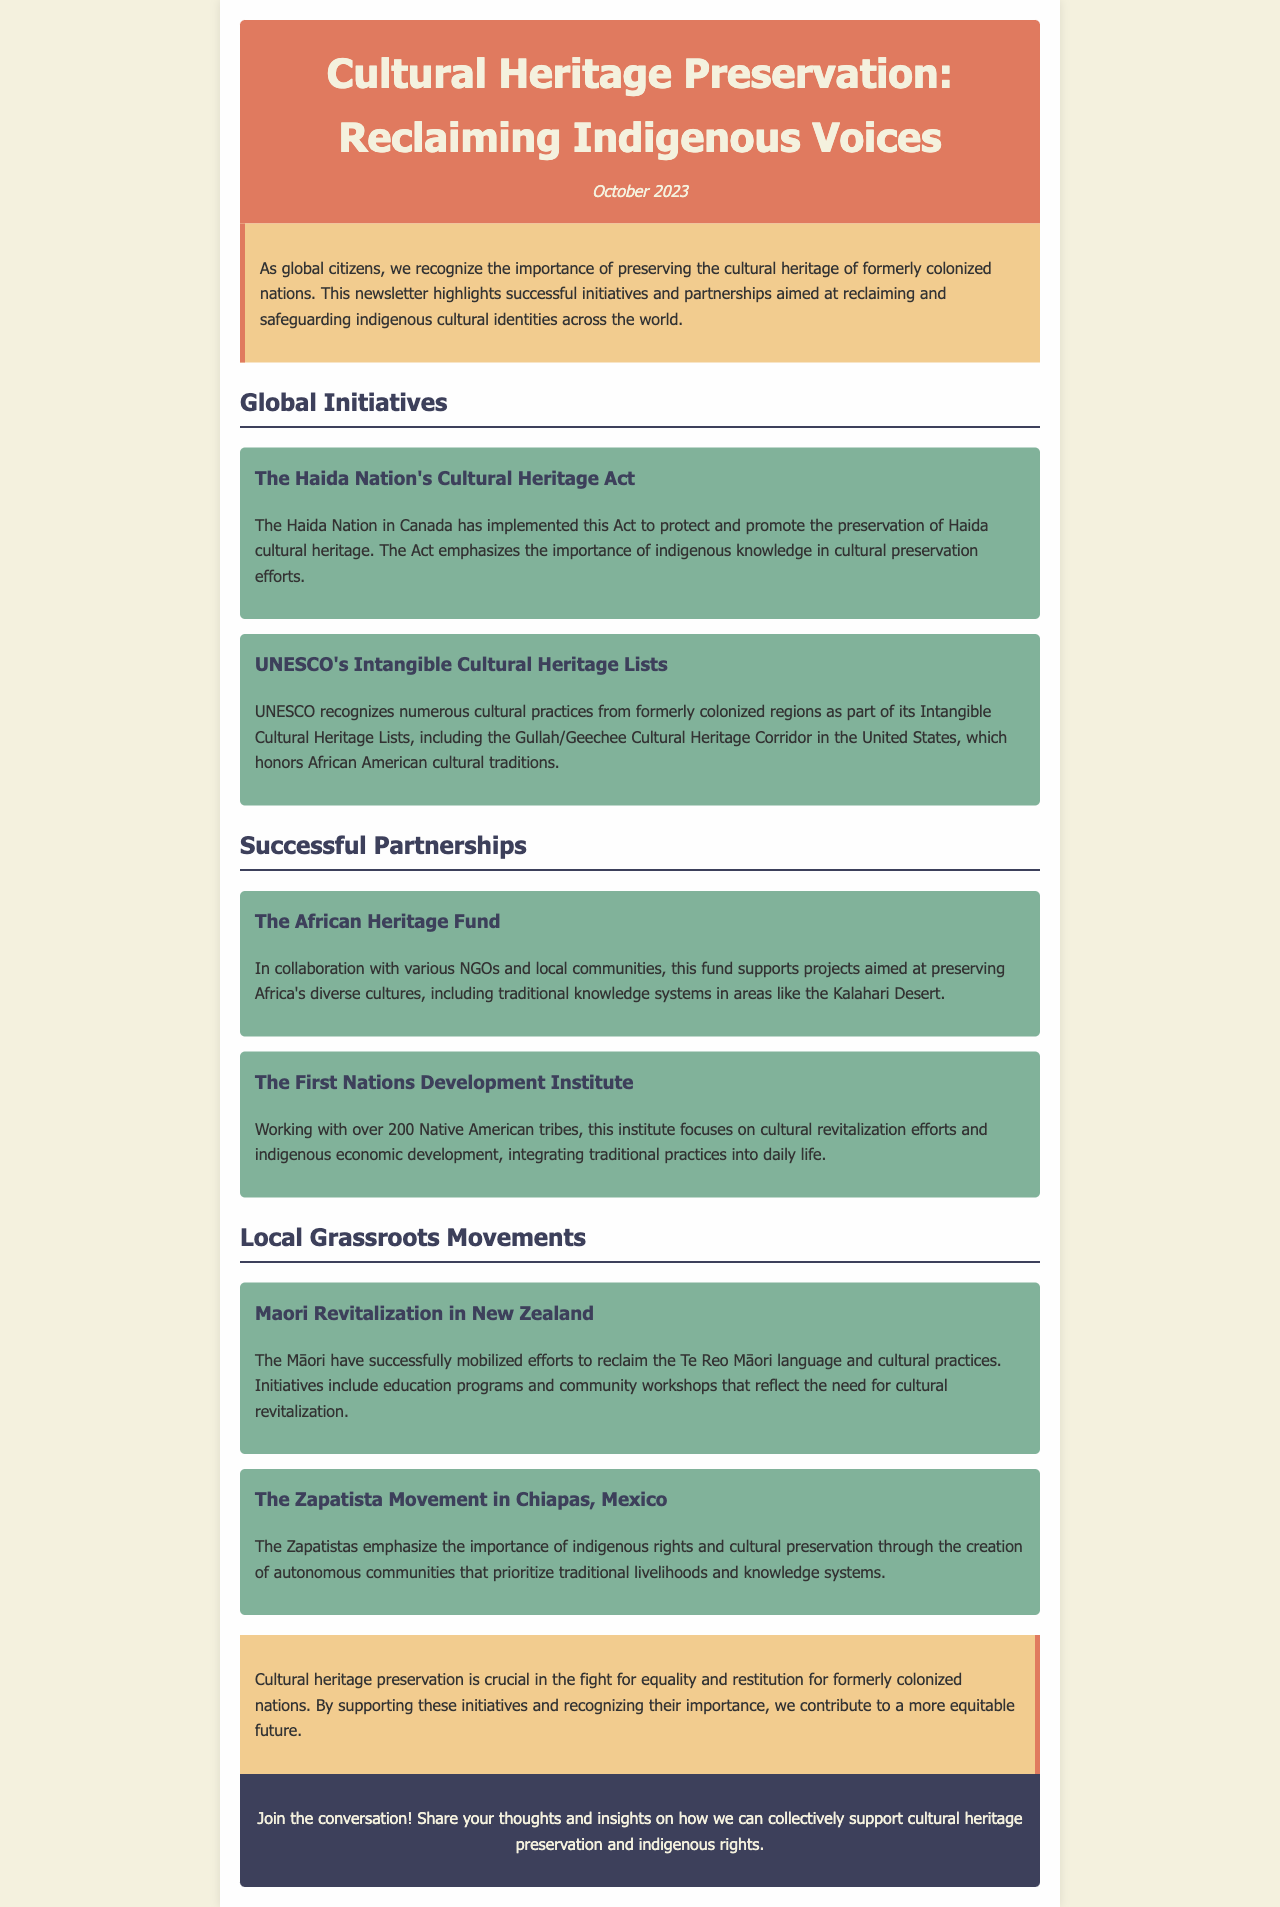What is the title of the newsletter? The title is prominently displayed at the top of the document.
Answer: Cultural Heritage Preservation: Reclaiming Indigenous Voices What date is the newsletter published? The publication date is mentioned below the title in the header.
Answer: October 2023 What initiative is focused on the Haida Nation? The name of the initiative is clearly stated in the section about global initiatives.
Answer: The Haida Nation's Cultural Heritage Act Which cultural heritage corridor is recognized by UNESCO? The specific cultural corridor is mentioned in the UNESCO initiative description.
Answer: Gullah/Geechee Cultural Heritage Corridor How many Native American tribes does the First Nations Development Institute work with? The number of tribes is provided in the partnership section describing the institute.
Answer: Over 200 Native American tribes What movement is associated with language revitalization in New Zealand? The movement's name is identified in the local grassroots movements section.
Answer: Maori Revitalization What is a focus of the Zapatista Movement in Chiapas? The focus is specified in the description of the Zapatista movement in the document.
Answer: Indigenous rights and cultural preservation What background color is used for the conclusion section? The specific color for the conclusion section is mentioned in the styling description.
Answer: Light yellow (f2cc8f) 